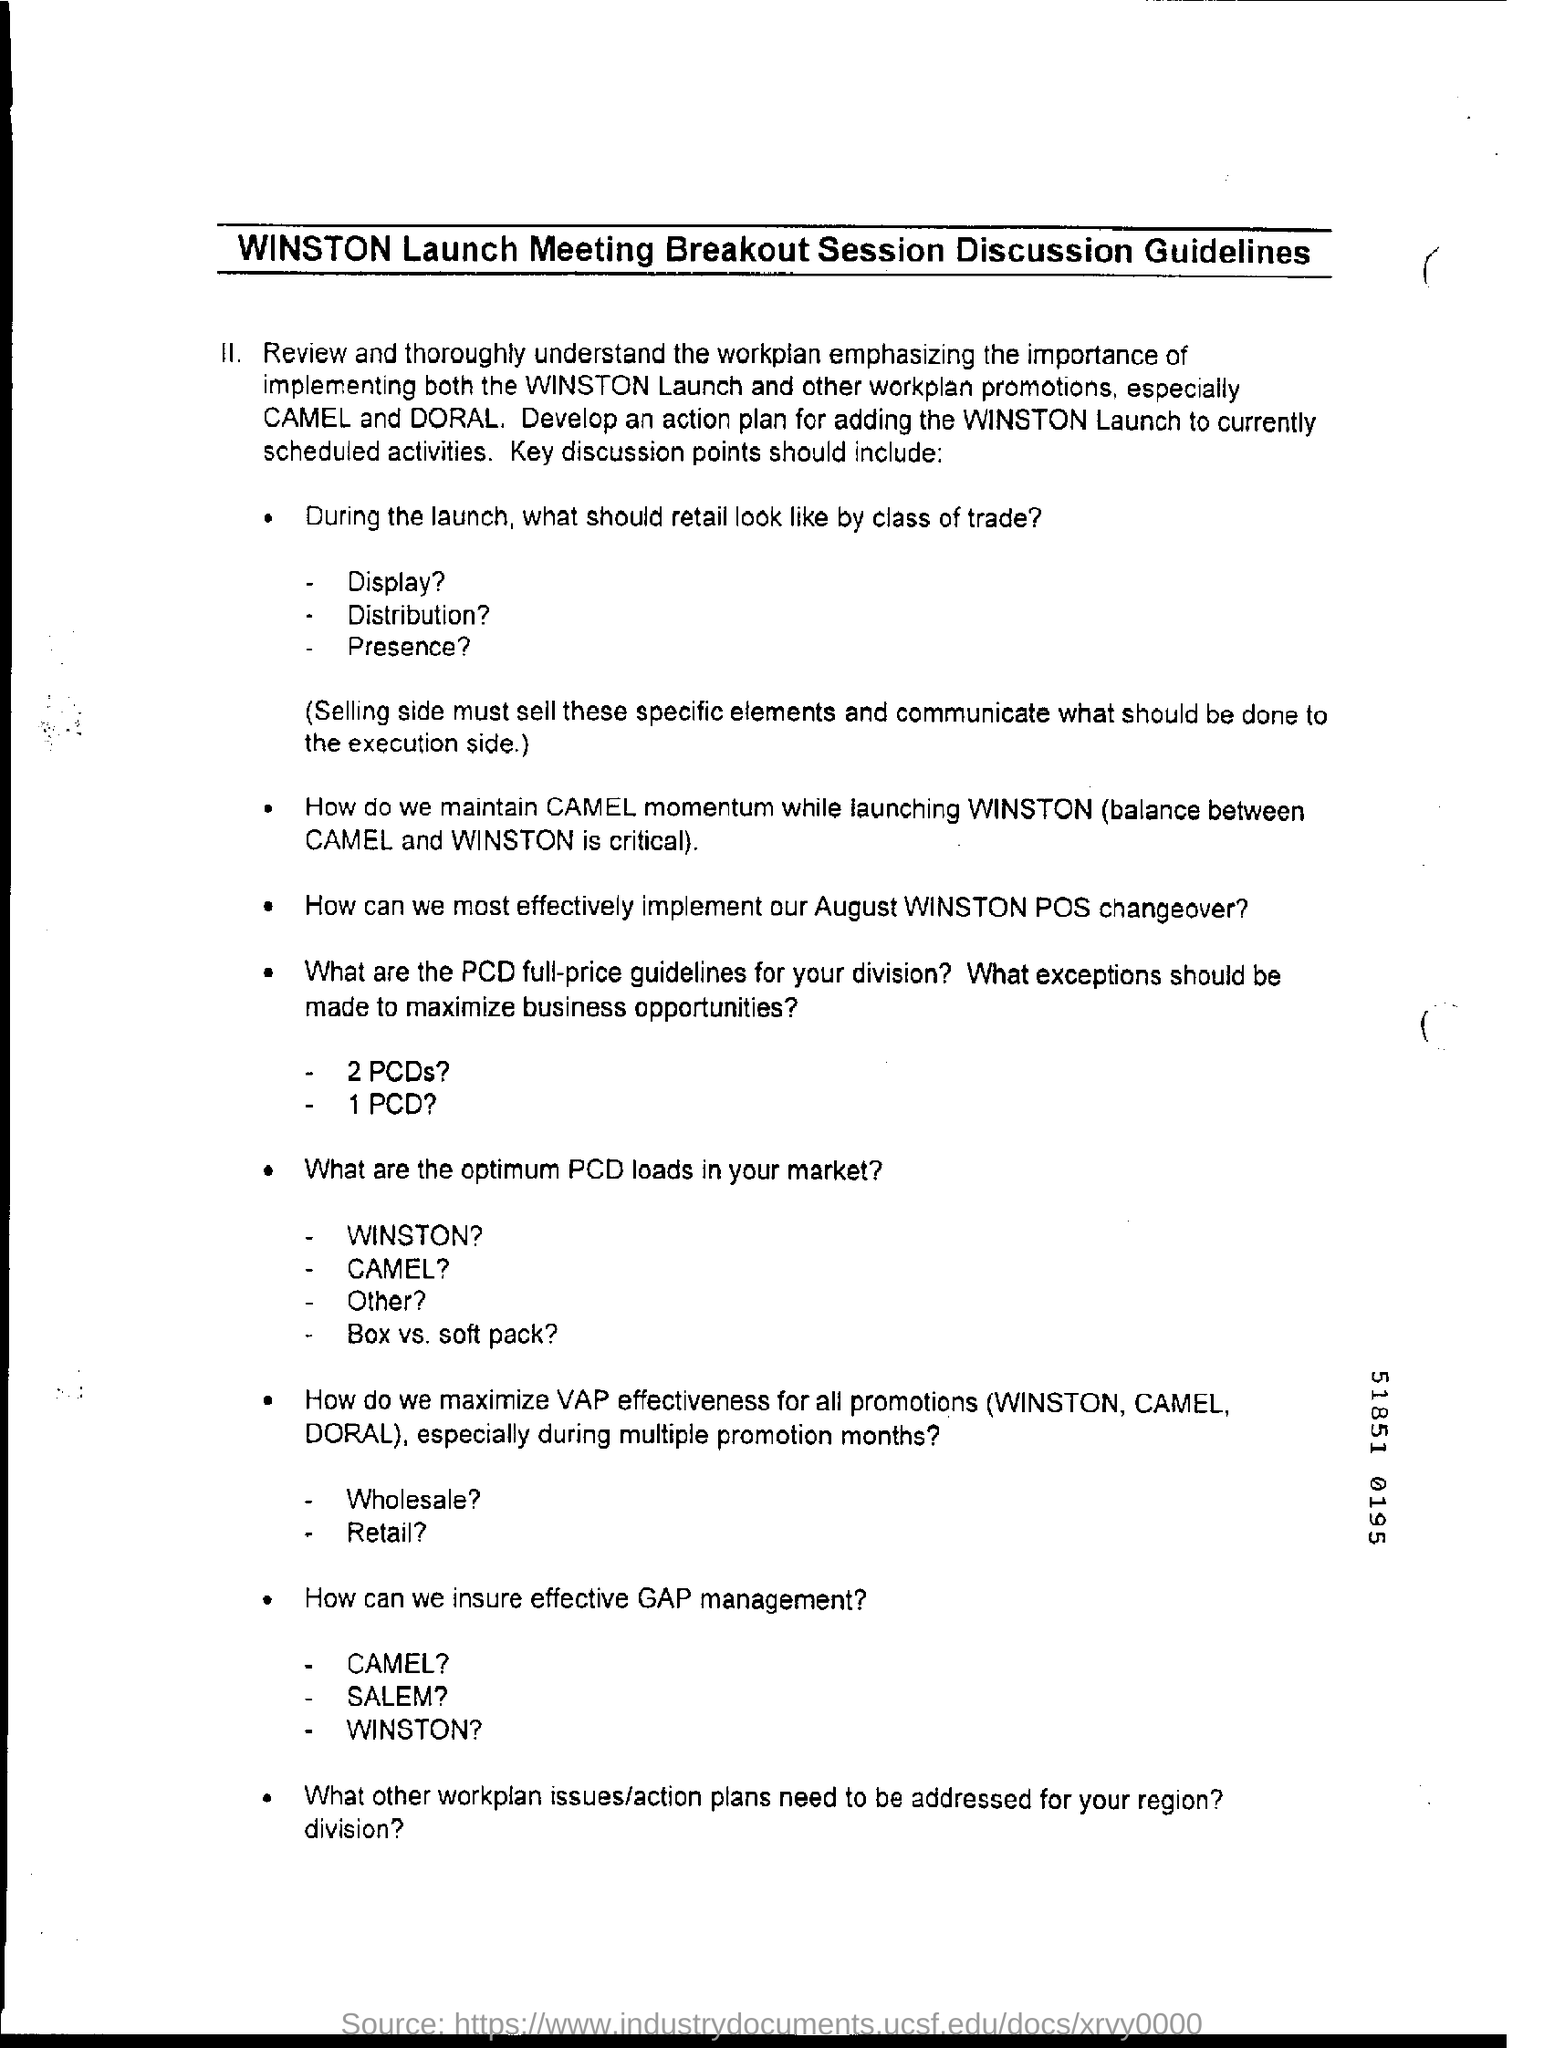What are the other workplan promotions?
Provide a succinct answer. CAMEL and DORAL. 